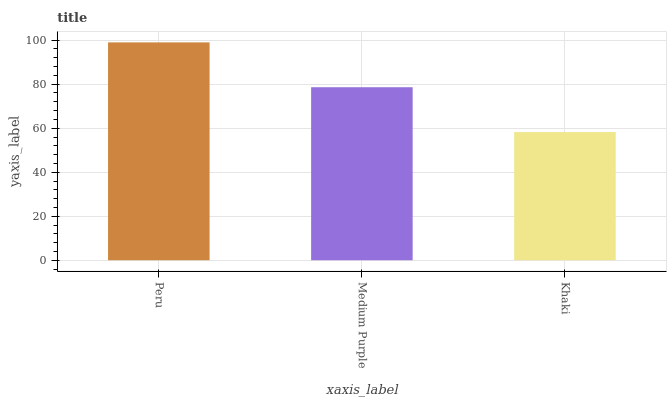Is Medium Purple the minimum?
Answer yes or no. No. Is Medium Purple the maximum?
Answer yes or no. No. Is Peru greater than Medium Purple?
Answer yes or no. Yes. Is Medium Purple less than Peru?
Answer yes or no. Yes. Is Medium Purple greater than Peru?
Answer yes or no. No. Is Peru less than Medium Purple?
Answer yes or no. No. Is Medium Purple the high median?
Answer yes or no. Yes. Is Medium Purple the low median?
Answer yes or no. Yes. Is Khaki the high median?
Answer yes or no. No. Is Khaki the low median?
Answer yes or no. No. 